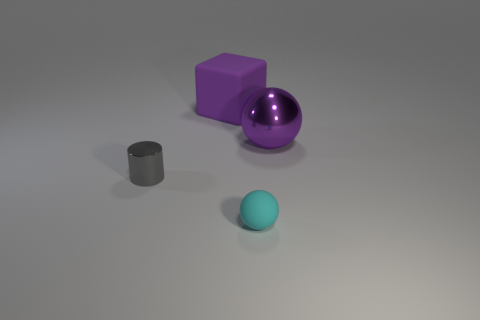Is the shape of the shiny thing on the right side of the gray metal object the same as  the big matte object?
Your response must be concise. No. There is a object that is the same material as the big purple ball; what is its color?
Ensure brevity in your answer.  Gray. What number of objects have the same material as the purple block?
Your response must be concise. 1. The small cylinder that is in front of the purple object on the left side of the tiny cyan ball that is to the left of the large ball is what color?
Your response must be concise. Gray. Is the size of the purple matte block the same as the purple metal sphere?
Provide a succinct answer. Yes. Is there any other thing that has the same shape as the big matte thing?
Your answer should be very brief. No. What number of things are either purple objects that are in front of the big purple matte block or large purple balls?
Give a very brief answer. 1. Do the gray metal object and the small cyan rubber thing have the same shape?
Offer a terse response. No. What color is the big metallic ball?
Your response must be concise. Purple. What number of small things are either gray shiny objects or cyan objects?
Your response must be concise. 2. 